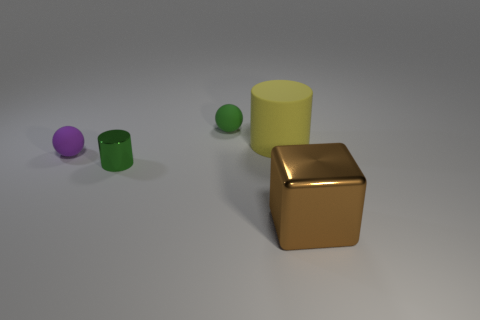Is the number of yellow matte cylinders less than the number of shiny things?
Offer a terse response. Yes. There is a small green thing that is in front of the matte cylinder; what is it made of?
Make the answer very short. Metal. What is the material of the green ball that is the same size as the green cylinder?
Make the answer very short. Rubber. The tiny green thing left of the small rubber ball on the right side of the metallic thing to the left of the big brown object is made of what material?
Your response must be concise. Metal. Is the size of the matte sphere that is on the left side of the green rubber thing the same as the tiny green ball?
Give a very brief answer. Yes. Are there more red metallic blocks than large brown objects?
Offer a terse response. No. What number of small things are either yellow rubber things or metal cylinders?
Your response must be concise. 1. How many other things are the same color as the rubber cylinder?
Offer a very short reply. 0. What number of small balls have the same material as the large yellow cylinder?
Offer a very short reply. 2. Do the big object right of the yellow object and the big rubber object have the same color?
Provide a succinct answer. No. 